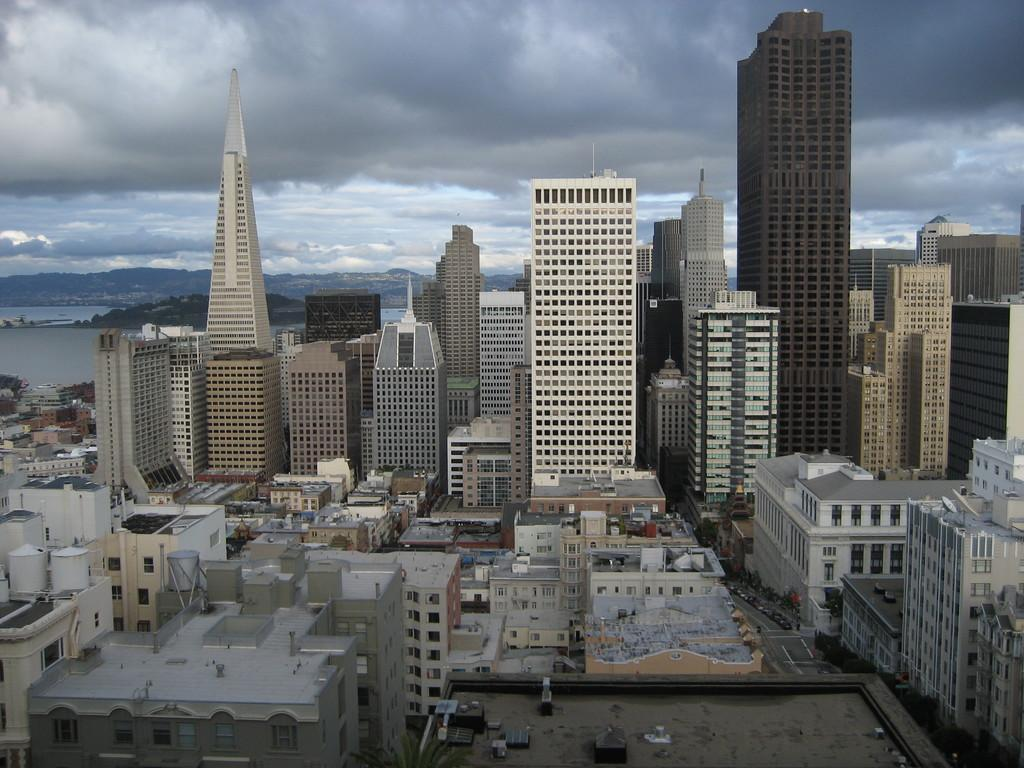What structures are located in the middle of the image? There are buildings in the middle of the image. What type of natural formation can be seen in the background of the image? There are mountains in the background of the image. What is the condition of the sky in the image? The sky is cloudy at the top of the image. What type of animal is floating in the sky with a balloon in the image? There is no animal or balloon present in the image. How does the memory of the mountains affect the buildings in the image? There is no mention of memory in the image, and the mountains and buildings are separate entities. 